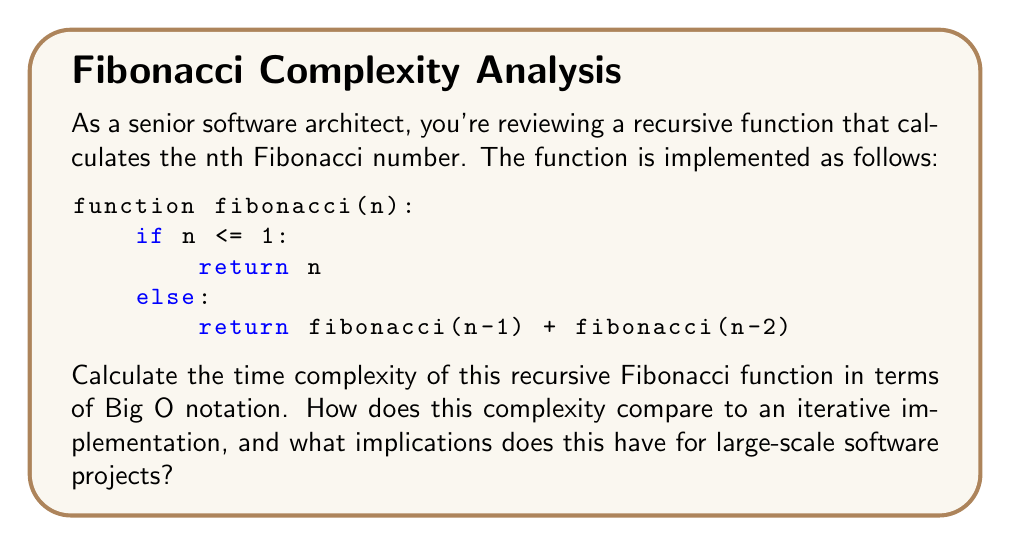Show me your answer to this math problem. To calculate the time complexity of this recursive Fibonacci function, we need to analyze the number of function calls made:

1. Let $T(n)$ be the number of function calls for input $n$.
2. For $n \leq 1$, $T(n) = 1$ (base case).
3. For $n > 1$, $T(n) = T(n-1) + T(n-2) + 1$ (recursive case).

This recurrence relation is similar to the Fibonacci sequence itself, but grows even faster. We can prove that $T(n)$ is bounded by:

$$ c_1 \phi^n \leq T(n) \leq c_2 \phi^n $$

Where $\phi = \frac{1 + \sqrt{5}}{2} \approx 1.618$ (the golden ratio) and $c_1, c_2$ are constants.

Using the Master Theorem or substitution method, we can conclude that the time complexity is:

$$ O(\phi^n) $$

This is exponential time complexity, which is much worse than the linear time complexity $O(n)$ of an iterative implementation.

Implications for large-scale software projects:
1. Performance: The recursive implementation will be significantly slower for large $n$.
2. Stack overflow: Deep recursion may cause stack overflow for large $n$.
3. Scalability: The exponential growth makes it impractical for large inputs.
4. Resource usage: Excessive CPU and memory consumption for large inputs.

As a senior software architect, you should recommend using an iterative implementation or dynamic programming approach for better performance and scalability in large-scale projects.
Answer: The time complexity of the recursive Fibonacci function is $O(\phi^n)$, where $\phi \approx 1.618$ is the golden ratio. This is exponential time complexity, which is significantly less efficient than the $O(n)$ time complexity of an iterative implementation. 